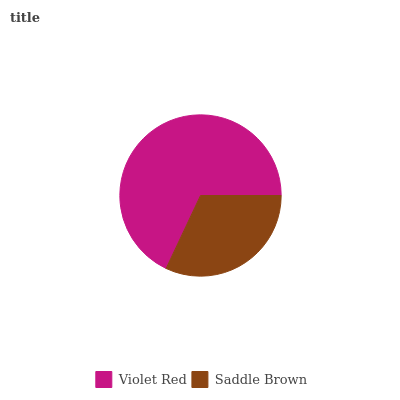Is Saddle Brown the minimum?
Answer yes or no. Yes. Is Violet Red the maximum?
Answer yes or no. Yes. Is Saddle Brown the maximum?
Answer yes or no. No. Is Violet Red greater than Saddle Brown?
Answer yes or no. Yes. Is Saddle Brown less than Violet Red?
Answer yes or no. Yes. Is Saddle Brown greater than Violet Red?
Answer yes or no. No. Is Violet Red less than Saddle Brown?
Answer yes or no. No. Is Violet Red the high median?
Answer yes or no. Yes. Is Saddle Brown the low median?
Answer yes or no. Yes. Is Saddle Brown the high median?
Answer yes or no. No. Is Violet Red the low median?
Answer yes or no. No. 